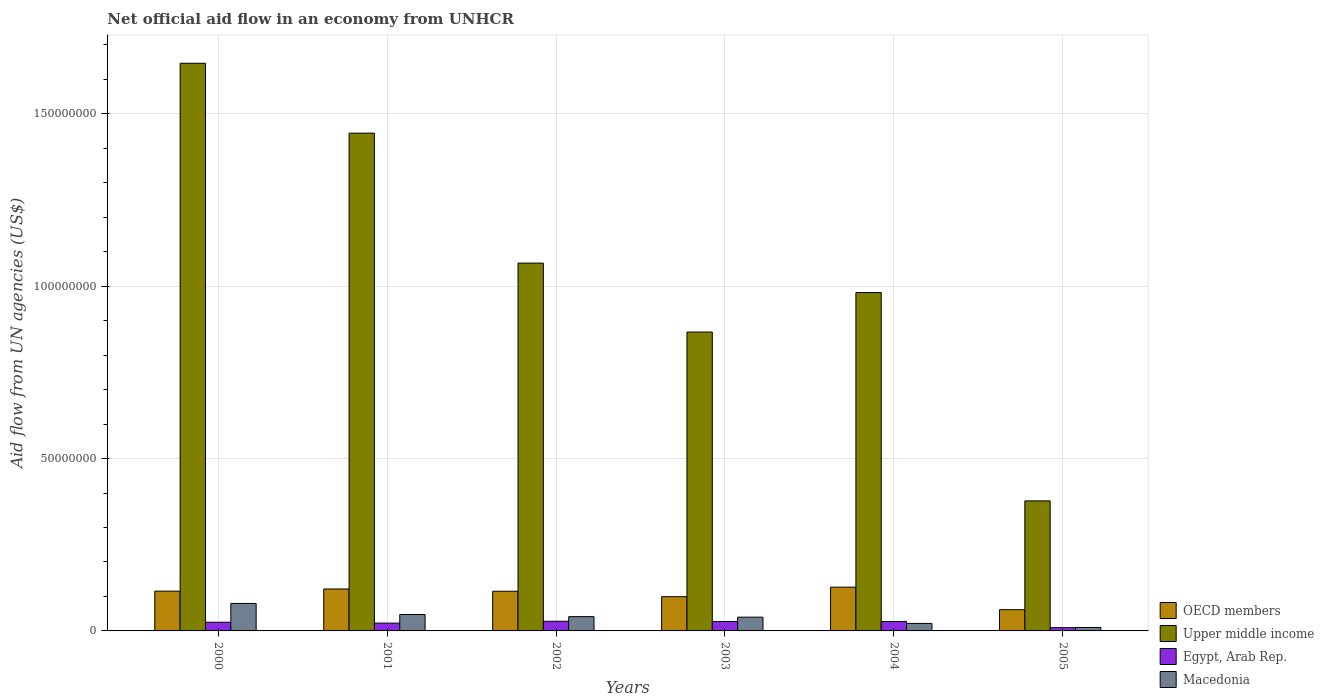How many different coloured bars are there?
Make the answer very short. 4. Are the number of bars per tick equal to the number of legend labels?
Keep it short and to the point. Yes. Are the number of bars on each tick of the X-axis equal?
Offer a very short reply. Yes. What is the label of the 4th group of bars from the left?
Your answer should be compact. 2003. In how many cases, is the number of bars for a given year not equal to the number of legend labels?
Give a very brief answer. 0. What is the net official aid flow in Macedonia in 2005?
Offer a very short reply. 1.00e+06. Across all years, what is the maximum net official aid flow in Egypt, Arab Rep.?
Make the answer very short. 2.80e+06. Across all years, what is the minimum net official aid flow in Macedonia?
Keep it short and to the point. 1.00e+06. What is the total net official aid flow in OECD members in the graph?
Your answer should be very brief. 6.40e+07. What is the difference between the net official aid flow in Macedonia in 2000 and that in 2001?
Your response must be concise. 3.21e+06. What is the difference between the net official aid flow in OECD members in 2003 and the net official aid flow in Upper middle income in 2004?
Your answer should be very brief. -8.82e+07. What is the average net official aid flow in Egypt, Arab Rep. per year?
Your response must be concise. 2.33e+06. In the year 2004, what is the difference between the net official aid flow in Egypt, Arab Rep. and net official aid flow in Upper middle income?
Keep it short and to the point. -9.54e+07. In how many years, is the net official aid flow in Egypt, Arab Rep. greater than 80000000 US$?
Your answer should be very brief. 0. What is the ratio of the net official aid flow in Egypt, Arab Rep. in 2001 to that in 2002?
Offer a terse response. 0.81. Is the difference between the net official aid flow in Egypt, Arab Rep. in 2000 and 2003 greater than the difference between the net official aid flow in Upper middle income in 2000 and 2003?
Provide a succinct answer. No. What is the difference between the highest and the second highest net official aid flow in Upper middle income?
Your answer should be very brief. 2.03e+07. What is the difference between the highest and the lowest net official aid flow in OECD members?
Ensure brevity in your answer.  6.54e+06. Is the sum of the net official aid flow in Upper middle income in 2000 and 2004 greater than the maximum net official aid flow in Macedonia across all years?
Your answer should be compact. Yes. Is it the case that in every year, the sum of the net official aid flow in Upper middle income and net official aid flow in Egypt, Arab Rep. is greater than the sum of net official aid flow in OECD members and net official aid flow in Macedonia?
Your response must be concise. No. What does the 3rd bar from the left in 2000 represents?
Keep it short and to the point. Egypt, Arab Rep. What does the 4th bar from the right in 2005 represents?
Ensure brevity in your answer.  OECD members. Are all the bars in the graph horizontal?
Your answer should be very brief. No. How many years are there in the graph?
Your answer should be compact. 6. What is the difference between two consecutive major ticks on the Y-axis?
Ensure brevity in your answer.  5.00e+07. Does the graph contain any zero values?
Your response must be concise. No. Where does the legend appear in the graph?
Provide a short and direct response. Bottom right. How are the legend labels stacked?
Provide a succinct answer. Vertical. What is the title of the graph?
Offer a very short reply. Net official aid flow in an economy from UNHCR. Does "Palau" appear as one of the legend labels in the graph?
Make the answer very short. No. What is the label or title of the Y-axis?
Offer a very short reply. Aid flow from UN agencies (US$). What is the Aid flow from UN agencies (US$) of OECD members in 2000?
Your response must be concise. 1.15e+07. What is the Aid flow from UN agencies (US$) of Upper middle income in 2000?
Ensure brevity in your answer.  1.65e+08. What is the Aid flow from UN agencies (US$) in Egypt, Arab Rep. in 2000?
Your answer should be very brief. 2.52e+06. What is the Aid flow from UN agencies (US$) of Macedonia in 2000?
Provide a succinct answer. 7.97e+06. What is the Aid flow from UN agencies (US$) of OECD members in 2001?
Give a very brief answer. 1.22e+07. What is the Aid flow from UN agencies (US$) in Upper middle income in 2001?
Your response must be concise. 1.44e+08. What is the Aid flow from UN agencies (US$) of Egypt, Arab Rep. in 2001?
Provide a succinct answer. 2.27e+06. What is the Aid flow from UN agencies (US$) of Macedonia in 2001?
Offer a very short reply. 4.76e+06. What is the Aid flow from UN agencies (US$) in OECD members in 2002?
Keep it short and to the point. 1.15e+07. What is the Aid flow from UN agencies (US$) of Upper middle income in 2002?
Offer a very short reply. 1.07e+08. What is the Aid flow from UN agencies (US$) of Egypt, Arab Rep. in 2002?
Give a very brief answer. 2.80e+06. What is the Aid flow from UN agencies (US$) in Macedonia in 2002?
Ensure brevity in your answer.  4.14e+06. What is the Aid flow from UN agencies (US$) in OECD members in 2003?
Keep it short and to the point. 9.93e+06. What is the Aid flow from UN agencies (US$) of Upper middle income in 2003?
Your answer should be compact. 8.67e+07. What is the Aid flow from UN agencies (US$) of Egypt, Arab Rep. in 2003?
Offer a very short reply. 2.72e+06. What is the Aid flow from UN agencies (US$) of Macedonia in 2003?
Provide a short and direct response. 3.99e+06. What is the Aid flow from UN agencies (US$) in OECD members in 2004?
Make the answer very short. 1.27e+07. What is the Aid flow from UN agencies (US$) in Upper middle income in 2004?
Give a very brief answer. 9.82e+07. What is the Aid flow from UN agencies (US$) of Egypt, Arab Rep. in 2004?
Ensure brevity in your answer.  2.73e+06. What is the Aid flow from UN agencies (US$) of Macedonia in 2004?
Ensure brevity in your answer.  2.18e+06. What is the Aid flow from UN agencies (US$) of OECD members in 2005?
Make the answer very short. 6.16e+06. What is the Aid flow from UN agencies (US$) of Upper middle income in 2005?
Ensure brevity in your answer.  3.77e+07. What is the Aid flow from UN agencies (US$) in Egypt, Arab Rep. in 2005?
Give a very brief answer. 9.40e+05. What is the Aid flow from UN agencies (US$) in Macedonia in 2005?
Your answer should be very brief. 1.00e+06. Across all years, what is the maximum Aid flow from UN agencies (US$) of OECD members?
Offer a terse response. 1.27e+07. Across all years, what is the maximum Aid flow from UN agencies (US$) in Upper middle income?
Your answer should be very brief. 1.65e+08. Across all years, what is the maximum Aid flow from UN agencies (US$) in Egypt, Arab Rep.?
Your answer should be compact. 2.80e+06. Across all years, what is the maximum Aid flow from UN agencies (US$) in Macedonia?
Provide a short and direct response. 7.97e+06. Across all years, what is the minimum Aid flow from UN agencies (US$) of OECD members?
Provide a succinct answer. 6.16e+06. Across all years, what is the minimum Aid flow from UN agencies (US$) of Upper middle income?
Your answer should be very brief. 3.77e+07. Across all years, what is the minimum Aid flow from UN agencies (US$) of Egypt, Arab Rep.?
Offer a terse response. 9.40e+05. What is the total Aid flow from UN agencies (US$) of OECD members in the graph?
Your answer should be compact. 6.40e+07. What is the total Aid flow from UN agencies (US$) in Upper middle income in the graph?
Offer a terse response. 6.38e+08. What is the total Aid flow from UN agencies (US$) in Egypt, Arab Rep. in the graph?
Provide a succinct answer. 1.40e+07. What is the total Aid flow from UN agencies (US$) in Macedonia in the graph?
Give a very brief answer. 2.40e+07. What is the difference between the Aid flow from UN agencies (US$) in OECD members in 2000 and that in 2001?
Your answer should be very brief. -6.30e+05. What is the difference between the Aid flow from UN agencies (US$) in Upper middle income in 2000 and that in 2001?
Ensure brevity in your answer.  2.03e+07. What is the difference between the Aid flow from UN agencies (US$) in Egypt, Arab Rep. in 2000 and that in 2001?
Your answer should be compact. 2.50e+05. What is the difference between the Aid flow from UN agencies (US$) of Macedonia in 2000 and that in 2001?
Ensure brevity in your answer.  3.21e+06. What is the difference between the Aid flow from UN agencies (US$) in Upper middle income in 2000 and that in 2002?
Your response must be concise. 5.80e+07. What is the difference between the Aid flow from UN agencies (US$) of Egypt, Arab Rep. in 2000 and that in 2002?
Give a very brief answer. -2.80e+05. What is the difference between the Aid flow from UN agencies (US$) in Macedonia in 2000 and that in 2002?
Offer a terse response. 3.83e+06. What is the difference between the Aid flow from UN agencies (US$) in OECD members in 2000 and that in 2003?
Provide a short and direct response. 1.61e+06. What is the difference between the Aid flow from UN agencies (US$) in Upper middle income in 2000 and that in 2003?
Keep it short and to the point. 7.80e+07. What is the difference between the Aid flow from UN agencies (US$) of Egypt, Arab Rep. in 2000 and that in 2003?
Keep it short and to the point. -2.00e+05. What is the difference between the Aid flow from UN agencies (US$) of Macedonia in 2000 and that in 2003?
Your response must be concise. 3.98e+06. What is the difference between the Aid flow from UN agencies (US$) of OECD members in 2000 and that in 2004?
Provide a short and direct response. -1.16e+06. What is the difference between the Aid flow from UN agencies (US$) of Upper middle income in 2000 and that in 2004?
Provide a short and direct response. 6.65e+07. What is the difference between the Aid flow from UN agencies (US$) of Macedonia in 2000 and that in 2004?
Offer a terse response. 5.79e+06. What is the difference between the Aid flow from UN agencies (US$) in OECD members in 2000 and that in 2005?
Offer a terse response. 5.38e+06. What is the difference between the Aid flow from UN agencies (US$) of Upper middle income in 2000 and that in 2005?
Your answer should be compact. 1.27e+08. What is the difference between the Aid flow from UN agencies (US$) in Egypt, Arab Rep. in 2000 and that in 2005?
Provide a short and direct response. 1.58e+06. What is the difference between the Aid flow from UN agencies (US$) in Macedonia in 2000 and that in 2005?
Give a very brief answer. 6.97e+06. What is the difference between the Aid flow from UN agencies (US$) in Upper middle income in 2001 and that in 2002?
Offer a terse response. 3.77e+07. What is the difference between the Aid flow from UN agencies (US$) in Egypt, Arab Rep. in 2001 and that in 2002?
Offer a very short reply. -5.30e+05. What is the difference between the Aid flow from UN agencies (US$) of Macedonia in 2001 and that in 2002?
Give a very brief answer. 6.20e+05. What is the difference between the Aid flow from UN agencies (US$) in OECD members in 2001 and that in 2003?
Provide a short and direct response. 2.24e+06. What is the difference between the Aid flow from UN agencies (US$) of Upper middle income in 2001 and that in 2003?
Offer a very short reply. 5.77e+07. What is the difference between the Aid flow from UN agencies (US$) in Egypt, Arab Rep. in 2001 and that in 2003?
Give a very brief answer. -4.50e+05. What is the difference between the Aid flow from UN agencies (US$) of Macedonia in 2001 and that in 2003?
Keep it short and to the point. 7.70e+05. What is the difference between the Aid flow from UN agencies (US$) in OECD members in 2001 and that in 2004?
Keep it short and to the point. -5.30e+05. What is the difference between the Aid flow from UN agencies (US$) in Upper middle income in 2001 and that in 2004?
Your response must be concise. 4.62e+07. What is the difference between the Aid flow from UN agencies (US$) in Egypt, Arab Rep. in 2001 and that in 2004?
Provide a succinct answer. -4.60e+05. What is the difference between the Aid flow from UN agencies (US$) in Macedonia in 2001 and that in 2004?
Your response must be concise. 2.58e+06. What is the difference between the Aid flow from UN agencies (US$) in OECD members in 2001 and that in 2005?
Your response must be concise. 6.01e+06. What is the difference between the Aid flow from UN agencies (US$) in Upper middle income in 2001 and that in 2005?
Your response must be concise. 1.07e+08. What is the difference between the Aid flow from UN agencies (US$) of Egypt, Arab Rep. in 2001 and that in 2005?
Keep it short and to the point. 1.33e+06. What is the difference between the Aid flow from UN agencies (US$) of Macedonia in 2001 and that in 2005?
Offer a terse response. 3.76e+06. What is the difference between the Aid flow from UN agencies (US$) of OECD members in 2002 and that in 2003?
Offer a terse response. 1.58e+06. What is the difference between the Aid flow from UN agencies (US$) in Egypt, Arab Rep. in 2002 and that in 2003?
Your answer should be very brief. 8.00e+04. What is the difference between the Aid flow from UN agencies (US$) of OECD members in 2002 and that in 2004?
Ensure brevity in your answer.  -1.19e+06. What is the difference between the Aid flow from UN agencies (US$) of Upper middle income in 2002 and that in 2004?
Offer a terse response. 8.54e+06. What is the difference between the Aid flow from UN agencies (US$) in Macedonia in 2002 and that in 2004?
Provide a succinct answer. 1.96e+06. What is the difference between the Aid flow from UN agencies (US$) of OECD members in 2002 and that in 2005?
Your response must be concise. 5.35e+06. What is the difference between the Aid flow from UN agencies (US$) of Upper middle income in 2002 and that in 2005?
Offer a very short reply. 6.90e+07. What is the difference between the Aid flow from UN agencies (US$) in Egypt, Arab Rep. in 2002 and that in 2005?
Your response must be concise. 1.86e+06. What is the difference between the Aid flow from UN agencies (US$) of Macedonia in 2002 and that in 2005?
Offer a terse response. 3.14e+06. What is the difference between the Aid flow from UN agencies (US$) in OECD members in 2003 and that in 2004?
Provide a short and direct response. -2.77e+06. What is the difference between the Aid flow from UN agencies (US$) in Upper middle income in 2003 and that in 2004?
Keep it short and to the point. -1.15e+07. What is the difference between the Aid flow from UN agencies (US$) in Macedonia in 2003 and that in 2004?
Your answer should be compact. 1.81e+06. What is the difference between the Aid flow from UN agencies (US$) of OECD members in 2003 and that in 2005?
Offer a very short reply. 3.77e+06. What is the difference between the Aid flow from UN agencies (US$) in Upper middle income in 2003 and that in 2005?
Your answer should be very brief. 4.90e+07. What is the difference between the Aid flow from UN agencies (US$) of Egypt, Arab Rep. in 2003 and that in 2005?
Offer a very short reply. 1.78e+06. What is the difference between the Aid flow from UN agencies (US$) in Macedonia in 2003 and that in 2005?
Give a very brief answer. 2.99e+06. What is the difference between the Aid flow from UN agencies (US$) in OECD members in 2004 and that in 2005?
Provide a short and direct response. 6.54e+06. What is the difference between the Aid flow from UN agencies (US$) of Upper middle income in 2004 and that in 2005?
Your answer should be very brief. 6.04e+07. What is the difference between the Aid flow from UN agencies (US$) in Egypt, Arab Rep. in 2004 and that in 2005?
Your answer should be compact. 1.79e+06. What is the difference between the Aid flow from UN agencies (US$) in Macedonia in 2004 and that in 2005?
Your answer should be compact. 1.18e+06. What is the difference between the Aid flow from UN agencies (US$) of OECD members in 2000 and the Aid flow from UN agencies (US$) of Upper middle income in 2001?
Your answer should be very brief. -1.33e+08. What is the difference between the Aid flow from UN agencies (US$) of OECD members in 2000 and the Aid flow from UN agencies (US$) of Egypt, Arab Rep. in 2001?
Give a very brief answer. 9.27e+06. What is the difference between the Aid flow from UN agencies (US$) of OECD members in 2000 and the Aid flow from UN agencies (US$) of Macedonia in 2001?
Make the answer very short. 6.78e+06. What is the difference between the Aid flow from UN agencies (US$) of Upper middle income in 2000 and the Aid flow from UN agencies (US$) of Egypt, Arab Rep. in 2001?
Keep it short and to the point. 1.62e+08. What is the difference between the Aid flow from UN agencies (US$) of Upper middle income in 2000 and the Aid flow from UN agencies (US$) of Macedonia in 2001?
Make the answer very short. 1.60e+08. What is the difference between the Aid flow from UN agencies (US$) in Egypt, Arab Rep. in 2000 and the Aid flow from UN agencies (US$) in Macedonia in 2001?
Provide a succinct answer. -2.24e+06. What is the difference between the Aid flow from UN agencies (US$) in OECD members in 2000 and the Aid flow from UN agencies (US$) in Upper middle income in 2002?
Your answer should be compact. -9.52e+07. What is the difference between the Aid flow from UN agencies (US$) in OECD members in 2000 and the Aid flow from UN agencies (US$) in Egypt, Arab Rep. in 2002?
Your response must be concise. 8.74e+06. What is the difference between the Aid flow from UN agencies (US$) of OECD members in 2000 and the Aid flow from UN agencies (US$) of Macedonia in 2002?
Your response must be concise. 7.40e+06. What is the difference between the Aid flow from UN agencies (US$) of Upper middle income in 2000 and the Aid flow from UN agencies (US$) of Egypt, Arab Rep. in 2002?
Ensure brevity in your answer.  1.62e+08. What is the difference between the Aid flow from UN agencies (US$) in Upper middle income in 2000 and the Aid flow from UN agencies (US$) in Macedonia in 2002?
Your answer should be very brief. 1.61e+08. What is the difference between the Aid flow from UN agencies (US$) of Egypt, Arab Rep. in 2000 and the Aid flow from UN agencies (US$) of Macedonia in 2002?
Ensure brevity in your answer.  -1.62e+06. What is the difference between the Aid flow from UN agencies (US$) in OECD members in 2000 and the Aid flow from UN agencies (US$) in Upper middle income in 2003?
Your answer should be compact. -7.52e+07. What is the difference between the Aid flow from UN agencies (US$) of OECD members in 2000 and the Aid flow from UN agencies (US$) of Egypt, Arab Rep. in 2003?
Offer a very short reply. 8.82e+06. What is the difference between the Aid flow from UN agencies (US$) of OECD members in 2000 and the Aid flow from UN agencies (US$) of Macedonia in 2003?
Provide a succinct answer. 7.55e+06. What is the difference between the Aid flow from UN agencies (US$) in Upper middle income in 2000 and the Aid flow from UN agencies (US$) in Egypt, Arab Rep. in 2003?
Provide a short and direct response. 1.62e+08. What is the difference between the Aid flow from UN agencies (US$) of Upper middle income in 2000 and the Aid flow from UN agencies (US$) of Macedonia in 2003?
Provide a short and direct response. 1.61e+08. What is the difference between the Aid flow from UN agencies (US$) of Egypt, Arab Rep. in 2000 and the Aid flow from UN agencies (US$) of Macedonia in 2003?
Ensure brevity in your answer.  -1.47e+06. What is the difference between the Aid flow from UN agencies (US$) of OECD members in 2000 and the Aid flow from UN agencies (US$) of Upper middle income in 2004?
Make the answer very short. -8.66e+07. What is the difference between the Aid flow from UN agencies (US$) in OECD members in 2000 and the Aid flow from UN agencies (US$) in Egypt, Arab Rep. in 2004?
Your answer should be compact. 8.81e+06. What is the difference between the Aid flow from UN agencies (US$) in OECD members in 2000 and the Aid flow from UN agencies (US$) in Macedonia in 2004?
Keep it short and to the point. 9.36e+06. What is the difference between the Aid flow from UN agencies (US$) in Upper middle income in 2000 and the Aid flow from UN agencies (US$) in Egypt, Arab Rep. in 2004?
Provide a succinct answer. 1.62e+08. What is the difference between the Aid flow from UN agencies (US$) of Upper middle income in 2000 and the Aid flow from UN agencies (US$) of Macedonia in 2004?
Make the answer very short. 1.63e+08. What is the difference between the Aid flow from UN agencies (US$) in OECD members in 2000 and the Aid flow from UN agencies (US$) in Upper middle income in 2005?
Keep it short and to the point. -2.62e+07. What is the difference between the Aid flow from UN agencies (US$) in OECD members in 2000 and the Aid flow from UN agencies (US$) in Egypt, Arab Rep. in 2005?
Provide a short and direct response. 1.06e+07. What is the difference between the Aid flow from UN agencies (US$) in OECD members in 2000 and the Aid flow from UN agencies (US$) in Macedonia in 2005?
Your answer should be very brief. 1.05e+07. What is the difference between the Aid flow from UN agencies (US$) of Upper middle income in 2000 and the Aid flow from UN agencies (US$) of Egypt, Arab Rep. in 2005?
Your response must be concise. 1.64e+08. What is the difference between the Aid flow from UN agencies (US$) in Upper middle income in 2000 and the Aid flow from UN agencies (US$) in Macedonia in 2005?
Your answer should be very brief. 1.64e+08. What is the difference between the Aid flow from UN agencies (US$) of Egypt, Arab Rep. in 2000 and the Aid flow from UN agencies (US$) of Macedonia in 2005?
Ensure brevity in your answer.  1.52e+06. What is the difference between the Aid flow from UN agencies (US$) of OECD members in 2001 and the Aid flow from UN agencies (US$) of Upper middle income in 2002?
Provide a short and direct response. -9.45e+07. What is the difference between the Aid flow from UN agencies (US$) in OECD members in 2001 and the Aid flow from UN agencies (US$) in Egypt, Arab Rep. in 2002?
Give a very brief answer. 9.37e+06. What is the difference between the Aid flow from UN agencies (US$) in OECD members in 2001 and the Aid flow from UN agencies (US$) in Macedonia in 2002?
Keep it short and to the point. 8.03e+06. What is the difference between the Aid flow from UN agencies (US$) of Upper middle income in 2001 and the Aid flow from UN agencies (US$) of Egypt, Arab Rep. in 2002?
Keep it short and to the point. 1.42e+08. What is the difference between the Aid flow from UN agencies (US$) in Upper middle income in 2001 and the Aid flow from UN agencies (US$) in Macedonia in 2002?
Your response must be concise. 1.40e+08. What is the difference between the Aid flow from UN agencies (US$) of Egypt, Arab Rep. in 2001 and the Aid flow from UN agencies (US$) of Macedonia in 2002?
Give a very brief answer. -1.87e+06. What is the difference between the Aid flow from UN agencies (US$) of OECD members in 2001 and the Aid flow from UN agencies (US$) of Upper middle income in 2003?
Give a very brief answer. -7.45e+07. What is the difference between the Aid flow from UN agencies (US$) of OECD members in 2001 and the Aid flow from UN agencies (US$) of Egypt, Arab Rep. in 2003?
Give a very brief answer. 9.45e+06. What is the difference between the Aid flow from UN agencies (US$) in OECD members in 2001 and the Aid flow from UN agencies (US$) in Macedonia in 2003?
Ensure brevity in your answer.  8.18e+06. What is the difference between the Aid flow from UN agencies (US$) of Upper middle income in 2001 and the Aid flow from UN agencies (US$) of Egypt, Arab Rep. in 2003?
Make the answer very short. 1.42e+08. What is the difference between the Aid flow from UN agencies (US$) in Upper middle income in 2001 and the Aid flow from UN agencies (US$) in Macedonia in 2003?
Your response must be concise. 1.40e+08. What is the difference between the Aid flow from UN agencies (US$) of Egypt, Arab Rep. in 2001 and the Aid flow from UN agencies (US$) of Macedonia in 2003?
Provide a succinct answer. -1.72e+06. What is the difference between the Aid flow from UN agencies (US$) of OECD members in 2001 and the Aid flow from UN agencies (US$) of Upper middle income in 2004?
Your response must be concise. -8.60e+07. What is the difference between the Aid flow from UN agencies (US$) of OECD members in 2001 and the Aid flow from UN agencies (US$) of Egypt, Arab Rep. in 2004?
Provide a succinct answer. 9.44e+06. What is the difference between the Aid flow from UN agencies (US$) of OECD members in 2001 and the Aid flow from UN agencies (US$) of Macedonia in 2004?
Your answer should be compact. 9.99e+06. What is the difference between the Aid flow from UN agencies (US$) of Upper middle income in 2001 and the Aid flow from UN agencies (US$) of Egypt, Arab Rep. in 2004?
Keep it short and to the point. 1.42e+08. What is the difference between the Aid flow from UN agencies (US$) of Upper middle income in 2001 and the Aid flow from UN agencies (US$) of Macedonia in 2004?
Your answer should be very brief. 1.42e+08. What is the difference between the Aid flow from UN agencies (US$) in Egypt, Arab Rep. in 2001 and the Aid flow from UN agencies (US$) in Macedonia in 2004?
Make the answer very short. 9.00e+04. What is the difference between the Aid flow from UN agencies (US$) of OECD members in 2001 and the Aid flow from UN agencies (US$) of Upper middle income in 2005?
Keep it short and to the point. -2.56e+07. What is the difference between the Aid flow from UN agencies (US$) in OECD members in 2001 and the Aid flow from UN agencies (US$) in Egypt, Arab Rep. in 2005?
Offer a very short reply. 1.12e+07. What is the difference between the Aid flow from UN agencies (US$) in OECD members in 2001 and the Aid flow from UN agencies (US$) in Macedonia in 2005?
Your response must be concise. 1.12e+07. What is the difference between the Aid flow from UN agencies (US$) in Upper middle income in 2001 and the Aid flow from UN agencies (US$) in Egypt, Arab Rep. in 2005?
Provide a succinct answer. 1.43e+08. What is the difference between the Aid flow from UN agencies (US$) of Upper middle income in 2001 and the Aid flow from UN agencies (US$) of Macedonia in 2005?
Your answer should be very brief. 1.43e+08. What is the difference between the Aid flow from UN agencies (US$) of Egypt, Arab Rep. in 2001 and the Aid flow from UN agencies (US$) of Macedonia in 2005?
Your answer should be very brief. 1.27e+06. What is the difference between the Aid flow from UN agencies (US$) in OECD members in 2002 and the Aid flow from UN agencies (US$) in Upper middle income in 2003?
Keep it short and to the point. -7.52e+07. What is the difference between the Aid flow from UN agencies (US$) in OECD members in 2002 and the Aid flow from UN agencies (US$) in Egypt, Arab Rep. in 2003?
Keep it short and to the point. 8.79e+06. What is the difference between the Aid flow from UN agencies (US$) of OECD members in 2002 and the Aid flow from UN agencies (US$) of Macedonia in 2003?
Your answer should be very brief. 7.52e+06. What is the difference between the Aid flow from UN agencies (US$) of Upper middle income in 2002 and the Aid flow from UN agencies (US$) of Egypt, Arab Rep. in 2003?
Offer a very short reply. 1.04e+08. What is the difference between the Aid flow from UN agencies (US$) in Upper middle income in 2002 and the Aid flow from UN agencies (US$) in Macedonia in 2003?
Offer a terse response. 1.03e+08. What is the difference between the Aid flow from UN agencies (US$) in Egypt, Arab Rep. in 2002 and the Aid flow from UN agencies (US$) in Macedonia in 2003?
Keep it short and to the point. -1.19e+06. What is the difference between the Aid flow from UN agencies (US$) of OECD members in 2002 and the Aid flow from UN agencies (US$) of Upper middle income in 2004?
Keep it short and to the point. -8.67e+07. What is the difference between the Aid flow from UN agencies (US$) in OECD members in 2002 and the Aid flow from UN agencies (US$) in Egypt, Arab Rep. in 2004?
Give a very brief answer. 8.78e+06. What is the difference between the Aid flow from UN agencies (US$) of OECD members in 2002 and the Aid flow from UN agencies (US$) of Macedonia in 2004?
Give a very brief answer. 9.33e+06. What is the difference between the Aid flow from UN agencies (US$) in Upper middle income in 2002 and the Aid flow from UN agencies (US$) in Egypt, Arab Rep. in 2004?
Offer a terse response. 1.04e+08. What is the difference between the Aid flow from UN agencies (US$) of Upper middle income in 2002 and the Aid flow from UN agencies (US$) of Macedonia in 2004?
Your response must be concise. 1.05e+08. What is the difference between the Aid flow from UN agencies (US$) of Egypt, Arab Rep. in 2002 and the Aid flow from UN agencies (US$) of Macedonia in 2004?
Your answer should be compact. 6.20e+05. What is the difference between the Aid flow from UN agencies (US$) of OECD members in 2002 and the Aid flow from UN agencies (US$) of Upper middle income in 2005?
Your answer should be very brief. -2.62e+07. What is the difference between the Aid flow from UN agencies (US$) in OECD members in 2002 and the Aid flow from UN agencies (US$) in Egypt, Arab Rep. in 2005?
Keep it short and to the point. 1.06e+07. What is the difference between the Aid flow from UN agencies (US$) of OECD members in 2002 and the Aid flow from UN agencies (US$) of Macedonia in 2005?
Offer a terse response. 1.05e+07. What is the difference between the Aid flow from UN agencies (US$) of Upper middle income in 2002 and the Aid flow from UN agencies (US$) of Egypt, Arab Rep. in 2005?
Your response must be concise. 1.06e+08. What is the difference between the Aid flow from UN agencies (US$) of Upper middle income in 2002 and the Aid flow from UN agencies (US$) of Macedonia in 2005?
Your answer should be compact. 1.06e+08. What is the difference between the Aid flow from UN agencies (US$) in Egypt, Arab Rep. in 2002 and the Aid flow from UN agencies (US$) in Macedonia in 2005?
Keep it short and to the point. 1.80e+06. What is the difference between the Aid flow from UN agencies (US$) in OECD members in 2003 and the Aid flow from UN agencies (US$) in Upper middle income in 2004?
Make the answer very short. -8.82e+07. What is the difference between the Aid flow from UN agencies (US$) in OECD members in 2003 and the Aid flow from UN agencies (US$) in Egypt, Arab Rep. in 2004?
Keep it short and to the point. 7.20e+06. What is the difference between the Aid flow from UN agencies (US$) of OECD members in 2003 and the Aid flow from UN agencies (US$) of Macedonia in 2004?
Provide a short and direct response. 7.75e+06. What is the difference between the Aid flow from UN agencies (US$) of Upper middle income in 2003 and the Aid flow from UN agencies (US$) of Egypt, Arab Rep. in 2004?
Offer a terse response. 8.40e+07. What is the difference between the Aid flow from UN agencies (US$) in Upper middle income in 2003 and the Aid flow from UN agencies (US$) in Macedonia in 2004?
Your answer should be compact. 8.45e+07. What is the difference between the Aid flow from UN agencies (US$) in Egypt, Arab Rep. in 2003 and the Aid flow from UN agencies (US$) in Macedonia in 2004?
Make the answer very short. 5.40e+05. What is the difference between the Aid flow from UN agencies (US$) of OECD members in 2003 and the Aid flow from UN agencies (US$) of Upper middle income in 2005?
Keep it short and to the point. -2.78e+07. What is the difference between the Aid flow from UN agencies (US$) in OECD members in 2003 and the Aid flow from UN agencies (US$) in Egypt, Arab Rep. in 2005?
Offer a terse response. 8.99e+06. What is the difference between the Aid flow from UN agencies (US$) in OECD members in 2003 and the Aid flow from UN agencies (US$) in Macedonia in 2005?
Your answer should be compact. 8.93e+06. What is the difference between the Aid flow from UN agencies (US$) in Upper middle income in 2003 and the Aid flow from UN agencies (US$) in Egypt, Arab Rep. in 2005?
Provide a succinct answer. 8.58e+07. What is the difference between the Aid flow from UN agencies (US$) in Upper middle income in 2003 and the Aid flow from UN agencies (US$) in Macedonia in 2005?
Keep it short and to the point. 8.57e+07. What is the difference between the Aid flow from UN agencies (US$) of Egypt, Arab Rep. in 2003 and the Aid flow from UN agencies (US$) of Macedonia in 2005?
Ensure brevity in your answer.  1.72e+06. What is the difference between the Aid flow from UN agencies (US$) of OECD members in 2004 and the Aid flow from UN agencies (US$) of Upper middle income in 2005?
Your answer should be compact. -2.50e+07. What is the difference between the Aid flow from UN agencies (US$) of OECD members in 2004 and the Aid flow from UN agencies (US$) of Egypt, Arab Rep. in 2005?
Give a very brief answer. 1.18e+07. What is the difference between the Aid flow from UN agencies (US$) of OECD members in 2004 and the Aid flow from UN agencies (US$) of Macedonia in 2005?
Your response must be concise. 1.17e+07. What is the difference between the Aid flow from UN agencies (US$) of Upper middle income in 2004 and the Aid flow from UN agencies (US$) of Egypt, Arab Rep. in 2005?
Give a very brief answer. 9.72e+07. What is the difference between the Aid flow from UN agencies (US$) in Upper middle income in 2004 and the Aid flow from UN agencies (US$) in Macedonia in 2005?
Your answer should be compact. 9.72e+07. What is the difference between the Aid flow from UN agencies (US$) of Egypt, Arab Rep. in 2004 and the Aid flow from UN agencies (US$) of Macedonia in 2005?
Your answer should be compact. 1.73e+06. What is the average Aid flow from UN agencies (US$) in OECD members per year?
Make the answer very short. 1.07e+07. What is the average Aid flow from UN agencies (US$) in Upper middle income per year?
Your answer should be compact. 1.06e+08. What is the average Aid flow from UN agencies (US$) of Egypt, Arab Rep. per year?
Your response must be concise. 2.33e+06. What is the average Aid flow from UN agencies (US$) of Macedonia per year?
Ensure brevity in your answer.  4.01e+06. In the year 2000, what is the difference between the Aid flow from UN agencies (US$) of OECD members and Aid flow from UN agencies (US$) of Upper middle income?
Give a very brief answer. -1.53e+08. In the year 2000, what is the difference between the Aid flow from UN agencies (US$) of OECD members and Aid flow from UN agencies (US$) of Egypt, Arab Rep.?
Offer a terse response. 9.02e+06. In the year 2000, what is the difference between the Aid flow from UN agencies (US$) of OECD members and Aid flow from UN agencies (US$) of Macedonia?
Ensure brevity in your answer.  3.57e+06. In the year 2000, what is the difference between the Aid flow from UN agencies (US$) in Upper middle income and Aid flow from UN agencies (US$) in Egypt, Arab Rep.?
Your response must be concise. 1.62e+08. In the year 2000, what is the difference between the Aid flow from UN agencies (US$) of Upper middle income and Aid flow from UN agencies (US$) of Macedonia?
Keep it short and to the point. 1.57e+08. In the year 2000, what is the difference between the Aid flow from UN agencies (US$) of Egypt, Arab Rep. and Aid flow from UN agencies (US$) of Macedonia?
Your response must be concise. -5.45e+06. In the year 2001, what is the difference between the Aid flow from UN agencies (US$) in OECD members and Aid flow from UN agencies (US$) in Upper middle income?
Provide a short and direct response. -1.32e+08. In the year 2001, what is the difference between the Aid flow from UN agencies (US$) in OECD members and Aid flow from UN agencies (US$) in Egypt, Arab Rep.?
Provide a short and direct response. 9.90e+06. In the year 2001, what is the difference between the Aid flow from UN agencies (US$) in OECD members and Aid flow from UN agencies (US$) in Macedonia?
Give a very brief answer. 7.41e+06. In the year 2001, what is the difference between the Aid flow from UN agencies (US$) of Upper middle income and Aid flow from UN agencies (US$) of Egypt, Arab Rep.?
Your answer should be compact. 1.42e+08. In the year 2001, what is the difference between the Aid flow from UN agencies (US$) in Upper middle income and Aid flow from UN agencies (US$) in Macedonia?
Offer a terse response. 1.40e+08. In the year 2001, what is the difference between the Aid flow from UN agencies (US$) in Egypt, Arab Rep. and Aid flow from UN agencies (US$) in Macedonia?
Your answer should be compact. -2.49e+06. In the year 2002, what is the difference between the Aid flow from UN agencies (US$) of OECD members and Aid flow from UN agencies (US$) of Upper middle income?
Offer a terse response. -9.52e+07. In the year 2002, what is the difference between the Aid flow from UN agencies (US$) in OECD members and Aid flow from UN agencies (US$) in Egypt, Arab Rep.?
Offer a very short reply. 8.71e+06. In the year 2002, what is the difference between the Aid flow from UN agencies (US$) of OECD members and Aid flow from UN agencies (US$) of Macedonia?
Offer a very short reply. 7.37e+06. In the year 2002, what is the difference between the Aid flow from UN agencies (US$) of Upper middle income and Aid flow from UN agencies (US$) of Egypt, Arab Rep.?
Ensure brevity in your answer.  1.04e+08. In the year 2002, what is the difference between the Aid flow from UN agencies (US$) in Upper middle income and Aid flow from UN agencies (US$) in Macedonia?
Offer a terse response. 1.03e+08. In the year 2002, what is the difference between the Aid flow from UN agencies (US$) of Egypt, Arab Rep. and Aid flow from UN agencies (US$) of Macedonia?
Keep it short and to the point. -1.34e+06. In the year 2003, what is the difference between the Aid flow from UN agencies (US$) of OECD members and Aid flow from UN agencies (US$) of Upper middle income?
Give a very brief answer. -7.68e+07. In the year 2003, what is the difference between the Aid flow from UN agencies (US$) of OECD members and Aid flow from UN agencies (US$) of Egypt, Arab Rep.?
Your answer should be very brief. 7.21e+06. In the year 2003, what is the difference between the Aid flow from UN agencies (US$) in OECD members and Aid flow from UN agencies (US$) in Macedonia?
Your response must be concise. 5.94e+06. In the year 2003, what is the difference between the Aid flow from UN agencies (US$) in Upper middle income and Aid flow from UN agencies (US$) in Egypt, Arab Rep.?
Give a very brief answer. 8.40e+07. In the year 2003, what is the difference between the Aid flow from UN agencies (US$) in Upper middle income and Aid flow from UN agencies (US$) in Macedonia?
Provide a succinct answer. 8.27e+07. In the year 2003, what is the difference between the Aid flow from UN agencies (US$) in Egypt, Arab Rep. and Aid flow from UN agencies (US$) in Macedonia?
Keep it short and to the point. -1.27e+06. In the year 2004, what is the difference between the Aid flow from UN agencies (US$) in OECD members and Aid flow from UN agencies (US$) in Upper middle income?
Give a very brief answer. -8.55e+07. In the year 2004, what is the difference between the Aid flow from UN agencies (US$) in OECD members and Aid flow from UN agencies (US$) in Egypt, Arab Rep.?
Give a very brief answer. 9.97e+06. In the year 2004, what is the difference between the Aid flow from UN agencies (US$) of OECD members and Aid flow from UN agencies (US$) of Macedonia?
Offer a terse response. 1.05e+07. In the year 2004, what is the difference between the Aid flow from UN agencies (US$) of Upper middle income and Aid flow from UN agencies (US$) of Egypt, Arab Rep.?
Offer a very short reply. 9.54e+07. In the year 2004, what is the difference between the Aid flow from UN agencies (US$) in Upper middle income and Aid flow from UN agencies (US$) in Macedonia?
Provide a short and direct response. 9.60e+07. In the year 2004, what is the difference between the Aid flow from UN agencies (US$) in Egypt, Arab Rep. and Aid flow from UN agencies (US$) in Macedonia?
Offer a terse response. 5.50e+05. In the year 2005, what is the difference between the Aid flow from UN agencies (US$) of OECD members and Aid flow from UN agencies (US$) of Upper middle income?
Provide a succinct answer. -3.16e+07. In the year 2005, what is the difference between the Aid flow from UN agencies (US$) in OECD members and Aid flow from UN agencies (US$) in Egypt, Arab Rep.?
Your answer should be compact. 5.22e+06. In the year 2005, what is the difference between the Aid flow from UN agencies (US$) in OECD members and Aid flow from UN agencies (US$) in Macedonia?
Provide a short and direct response. 5.16e+06. In the year 2005, what is the difference between the Aid flow from UN agencies (US$) in Upper middle income and Aid flow from UN agencies (US$) in Egypt, Arab Rep.?
Provide a succinct answer. 3.68e+07. In the year 2005, what is the difference between the Aid flow from UN agencies (US$) in Upper middle income and Aid flow from UN agencies (US$) in Macedonia?
Provide a succinct answer. 3.67e+07. In the year 2005, what is the difference between the Aid flow from UN agencies (US$) of Egypt, Arab Rep. and Aid flow from UN agencies (US$) of Macedonia?
Provide a short and direct response. -6.00e+04. What is the ratio of the Aid flow from UN agencies (US$) in OECD members in 2000 to that in 2001?
Ensure brevity in your answer.  0.95. What is the ratio of the Aid flow from UN agencies (US$) in Upper middle income in 2000 to that in 2001?
Your response must be concise. 1.14. What is the ratio of the Aid flow from UN agencies (US$) of Egypt, Arab Rep. in 2000 to that in 2001?
Give a very brief answer. 1.11. What is the ratio of the Aid flow from UN agencies (US$) of Macedonia in 2000 to that in 2001?
Ensure brevity in your answer.  1.67. What is the ratio of the Aid flow from UN agencies (US$) in Upper middle income in 2000 to that in 2002?
Ensure brevity in your answer.  1.54. What is the ratio of the Aid flow from UN agencies (US$) in Egypt, Arab Rep. in 2000 to that in 2002?
Keep it short and to the point. 0.9. What is the ratio of the Aid flow from UN agencies (US$) in Macedonia in 2000 to that in 2002?
Give a very brief answer. 1.93. What is the ratio of the Aid flow from UN agencies (US$) of OECD members in 2000 to that in 2003?
Your answer should be very brief. 1.16. What is the ratio of the Aid flow from UN agencies (US$) in Upper middle income in 2000 to that in 2003?
Provide a succinct answer. 1.9. What is the ratio of the Aid flow from UN agencies (US$) of Egypt, Arab Rep. in 2000 to that in 2003?
Offer a very short reply. 0.93. What is the ratio of the Aid flow from UN agencies (US$) of Macedonia in 2000 to that in 2003?
Provide a succinct answer. 2. What is the ratio of the Aid flow from UN agencies (US$) of OECD members in 2000 to that in 2004?
Keep it short and to the point. 0.91. What is the ratio of the Aid flow from UN agencies (US$) of Upper middle income in 2000 to that in 2004?
Provide a short and direct response. 1.68. What is the ratio of the Aid flow from UN agencies (US$) of Macedonia in 2000 to that in 2004?
Keep it short and to the point. 3.66. What is the ratio of the Aid flow from UN agencies (US$) in OECD members in 2000 to that in 2005?
Provide a succinct answer. 1.87. What is the ratio of the Aid flow from UN agencies (US$) in Upper middle income in 2000 to that in 2005?
Provide a short and direct response. 4.37. What is the ratio of the Aid flow from UN agencies (US$) of Egypt, Arab Rep. in 2000 to that in 2005?
Your response must be concise. 2.68. What is the ratio of the Aid flow from UN agencies (US$) in Macedonia in 2000 to that in 2005?
Your response must be concise. 7.97. What is the ratio of the Aid flow from UN agencies (US$) in OECD members in 2001 to that in 2002?
Your answer should be very brief. 1.06. What is the ratio of the Aid flow from UN agencies (US$) of Upper middle income in 2001 to that in 2002?
Offer a terse response. 1.35. What is the ratio of the Aid flow from UN agencies (US$) in Egypt, Arab Rep. in 2001 to that in 2002?
Keep it short and to the point. 0.81. What is the ratio of the Aid flow from UN agencies (US$) of Macedonia in 2001 to that in 2002?
Offer a terse response. 1.15. What is the ratio of the Aid flow from UN agencies (US$) in OECD members in 2001 to that in 2003?
Your answer should be compact. 1.23. What is the ratio of the Aid flow from UN agencies (US$) of Upper middle income in 2001 to that in 2003?
Your answer should be compact. 1.67. What is the ratio of the Aid flow from UN agencies (US$) in Egypt, Arab Rep. in 2001 to that in 2003?
Your answer should be compact. 0.83. What is the ratio of the Aid flow from UN agencies (US$) of Macedonia in 2001 to that in 2003?
Make the answer very short. 1.19. What is the ratio of the Aid flow from UN agencies (US$) of Upper middle income in 2001 to that in 2004?
Provide a succinct answer. 1.47. What is the ratio of the Aid flow from UN agencies (US$) of Egypt, Arab Rep. in 2001 to that in 2004?
Your response must be concise. 0.83. What is the ratio of the Aid flow from UN agencies (US$) of Macedonia in 2001 to that in 2004?
Make the answer very short. 2.18. What is the ratio of the Aid flow from UN agencies (US$) of OECD members in 2001 to that in 2005?
Provide a succinct answer. 1.98. What is the ratio of the Aid flow from UN agencies (US$) of Upper middle income in 2001 to that in 2005?
Your answer should be very brief. 3.83. What is the ratio of the Aid flow from UN agencies (US$) in Egypt, Arab Rep. in 2001 to that in 2005?
Offer a terse response. 2.41. What is the ratio of the Aid flow from UN agencies (US$) in Macedonia in 2001 to that in 2005?
Your answer should be compact. 4.76. What is the ratio of the Aid flow from UN agencies (US$) in OECD members in 2002 to that in 2003?
Make the answer very short. 1.16. What is the ratio of the Aid flow from UN agencies (US$) in Upper middle income in 2002 to that in 2003?
Provide a succinct answer. 1.23. What is the ratio of the Aid flow from UN agencies (US$) in Egypt, Arab Rep. in 2002 to that in 2003?
Your answer should be very brief. 1.03. What is the ratio of the Aid flow from UN agencies (US$) of Macedonia in 2002 to that in 2003?
Your response must be concise. 1.04. What is the ratio of the Aid flow from UN agencies (US$) of OECD members in 2002 to that in 2004?
Provide a short and direct response. 0.91. What is the ratio of the Aid flow from UN agencies (US$) of Upper middle income in 2002 to that in 2004?
Keep it short and to the point. 1.09. What is the ratio of the Aid flow from UN agencies (US$) of Egypt, Arab Rep. in 2002 to that in 2004?
Ensure brevity in your answer.  1.03. What is the ratio of the Aid flow from UN agencies (US$) in Macedonia in 2002 to that in 2004?
Make the answer very short. 1.9. What is the ratio of the Aid flow from UN agencies (US$) in OECD members in 2002 to that in 2005?
Your response must be concise. 1.87. What is the ratio of the Aid flow from UN agencies (US$) in Upper middle income in 2002 to that in 2005?
Offer a very short reply. 2.83. What is the ratio of the Aid flow from UN agencies (US$) in Egypt, Arab Rep. in 2002 to that in 2005?
Give a very brief answer. 2.98. What is the ratio of the Aid flow from UN agencies (US$) of Macedonia in 2002 to that in 2005?
Offer a terse response. 4.14. What is the ratio of the Aid flow from UN agencies (US$) of OECD members in 2003 to that in 2004?
Provide a succinct answer. 0.78. What is the ratio of the Aid flow from UN agencies (US$) of Upper middle income in 2003 to that in 2004?
Make the answer very short. 0.88. What is the ratio of the Aid flow from UN agencies (US$) of Egypt, Arab Rep. in 2003 to that in 2004?
Ensure brevity in your answer.  1. What is the ratio of the Aid flow from UN agencies (US$) in Macedonia in 2003 to that in 2004?
Give a very brief answer. 1.83. What is the ratio of the Aid flow from UN agencies (US$) of OECD members in 2003 to that in 2005?
Give a very brief answer. 1.61. What is the ratio of the Aid flow from UN agencies (US$) in Upper middle income in 2003 to that in 2005?
Give a very brief answer. 2.3. What is the ratio of the Aid flow from UN agencies (US$) in Egypt, Arab Rep. in 2003 to that in 2005?
Your answer should be very brief. 2.89. What is the ratio of the Aid flow from UN agencies (US$) of Macedonia in 2003 to that in 2005?
Provide a short and direct response. 3.99. What is the ratio of the Aid flow from UN agencies (US$) of OECD members in 2004 to that in 2005?
Make the answer very short. 2.06. What is the ratio of the Aid flow from UN agencies (US$) of Upper middle income in 2004 to that in 2005?
Provide a succinct answer. 2.6. What is the ratio of the Aid flow from UN agencies (US$) of Egypt, Arab Rep. in 2004 to that in 2005?
Offer a very short reply. 2.9. What is the ratio of the Aid flow from UN agencies (US$) of Macedonia in 2004 to that in 2005?
Provide a succinct answer. 2.18. What is the difference between the highest and the second highest Aid flow from UN agencies (US$) in OECD members?
Your answer should be compact. 5.30e+05. What is the difference between the highest and the second highest Aid flow from UN agencies (US$) of Upper middle income?
Make the answer very short. 2.03e+07. What is the difference between the highest and the second highest Aid flow from UN agencies (US$) of Egypt, Arab Rep.?
Provide a short and direct response. 7.00e+04. What is the difference between the highest and the second highest Aid flow from UN agencies (US$) of Macedonia?
Your response must be concise. 3.21e+06. What is the difference between the highest and the lowest Aid flow from UN agencies (US$) in OECD members?
Make the answer very short. 6.54e+06. What is the difference between the highest and the lowest Aid flow from UN agencies (US$) of Upper middle income?
Provide a succinct answer. 1.27e+08. What is the difference between the highest and the lowest Aid flow from UN agencies (US$) of Egypt, Arab Rep.?
Your response must be concise. 1.86e+06. What is the difference between the highest and the lowest Aid flow from UN agencies (US$) in Macedonia?
Your response must be concise. 6.97e+06. 